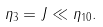Convert formula to latex. <formula><loc_0><loc_0><loc_500><loc_500>\eta _ { 3 } = J \ll \eta _ { 1 0 } .</formula> 